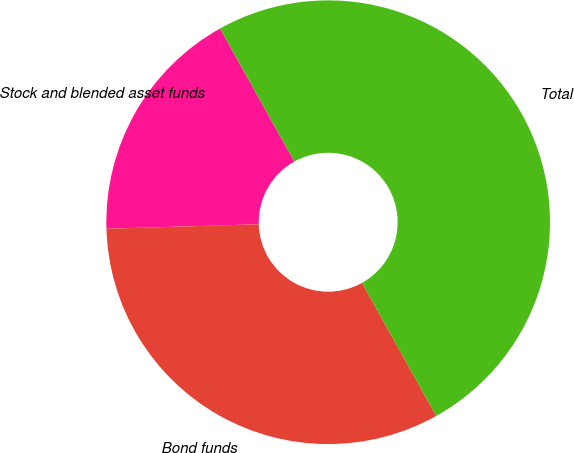Convert chart. <chart><loc_0><loc_0><loc_500><loc_500><pie_chart><fcel>Stock and blended asset funds<fcel>Bond funds<fcel>Total<nl><fcel>17.37%<fcel>32.63%<fcel>50.0%<nl></chart> 